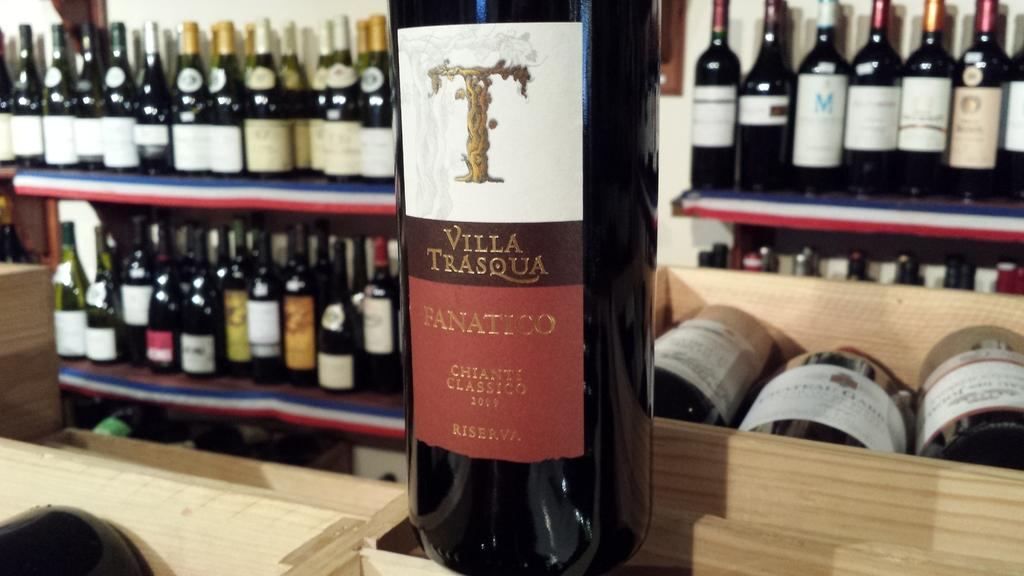Provide a one-sentence caption for the provided image. A wine label has a T over Villa Trasqua and Fanatico. 